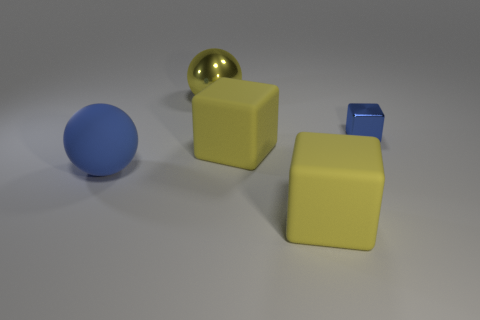There is a sphere behind the tiny blue metallic block; how big is it?
Offer a very short reply. Large. What material is the blue ball?
Give a very brief answer. Rubber. There is a big matte thing that is on the left side of the yellow shiny object; is it the same shape as the big shiny thing?
Your answer should be compact. Yes. The rubber object that is the same color as the tiny metal object is what size?
Your response must be concise. Large. Are there any brown shiny blocks that have the same size as the yellow metal sphere?
Offer a terse response. No. There is a yellow object on the left side of the large yellow cube behind the large blue rubber thing; are there any blue rubber balls that are behind it?
Make the answer very short. No. There is a big metallic object; is its color the same as the sphere that is in front of the tiny block?
Ensure brevity in your answer.  No. What is the big sphere in front of the large sphere right of the big ball in front of the large yellow metallic thing made of?
Offer a terse response. Rubber. What is the shape of the thing that is in front of the blue matte object?
Provide a succinct answer. Cube. The sphere that is the same material as the blue block is what size?
Make the answer very short. Large. 